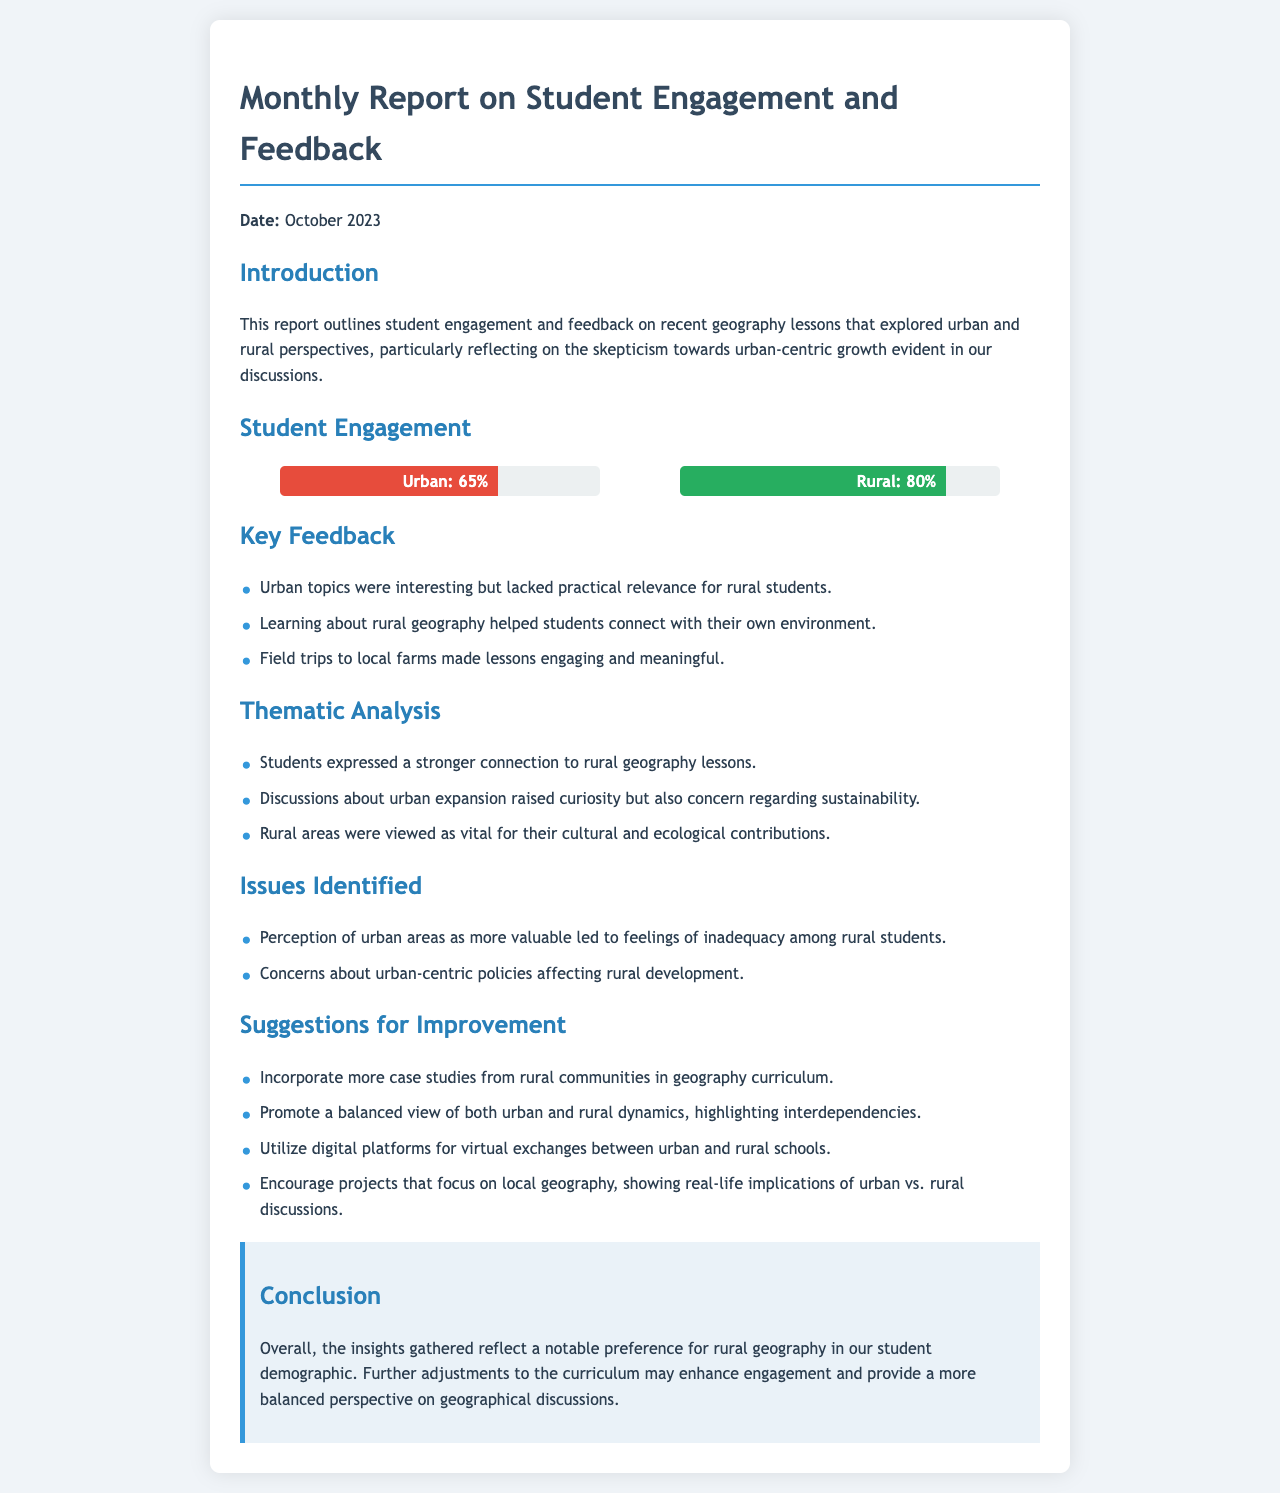What percentage of students engaged with urban topics? The document states that 65% of students engaged with urban topics based on the engagement chart.
Answer: 65% What percentage of students engaged with rural topics? According to the engagement chart, 80% of students engaged with rural topics.
Answer: 80% What date is listed on the report? The report specifies the date as October 2023.
Answer: October 2023 What was a key feedback point about urban topics? The document mentions that urban topics were interesting but lacked practical relevance for rural students.
Answer: Lacked practical relevance What was identified as an issue concerning urban areas? One issue identified was the perception of urban areas as more valuable, leading to feelings of inadequacy among rural students.
Answer: Feelings of inadequacy What suggestion was made to improve the geography curriculum? The document suggests incorporating more case studies from rural communities in the geography curriculum.
Answer: More case studies What main theme did students express a connection to? Students expressed a stronger connection to rural geography lessons, according to the thematic analysis.
Answer: Rural geography What did discussions about urban expansion raise? The document states that discussions about urban expansion raised curiosity but also concern regarding sustainability.
Answer: Concern regarding sustainability What is the overall conclusion of the report? The report concludes that there is a notable preference for rural geography among students, leading to suggestions for curriculum adjustments.
Answer: Notable preference for rural geography 